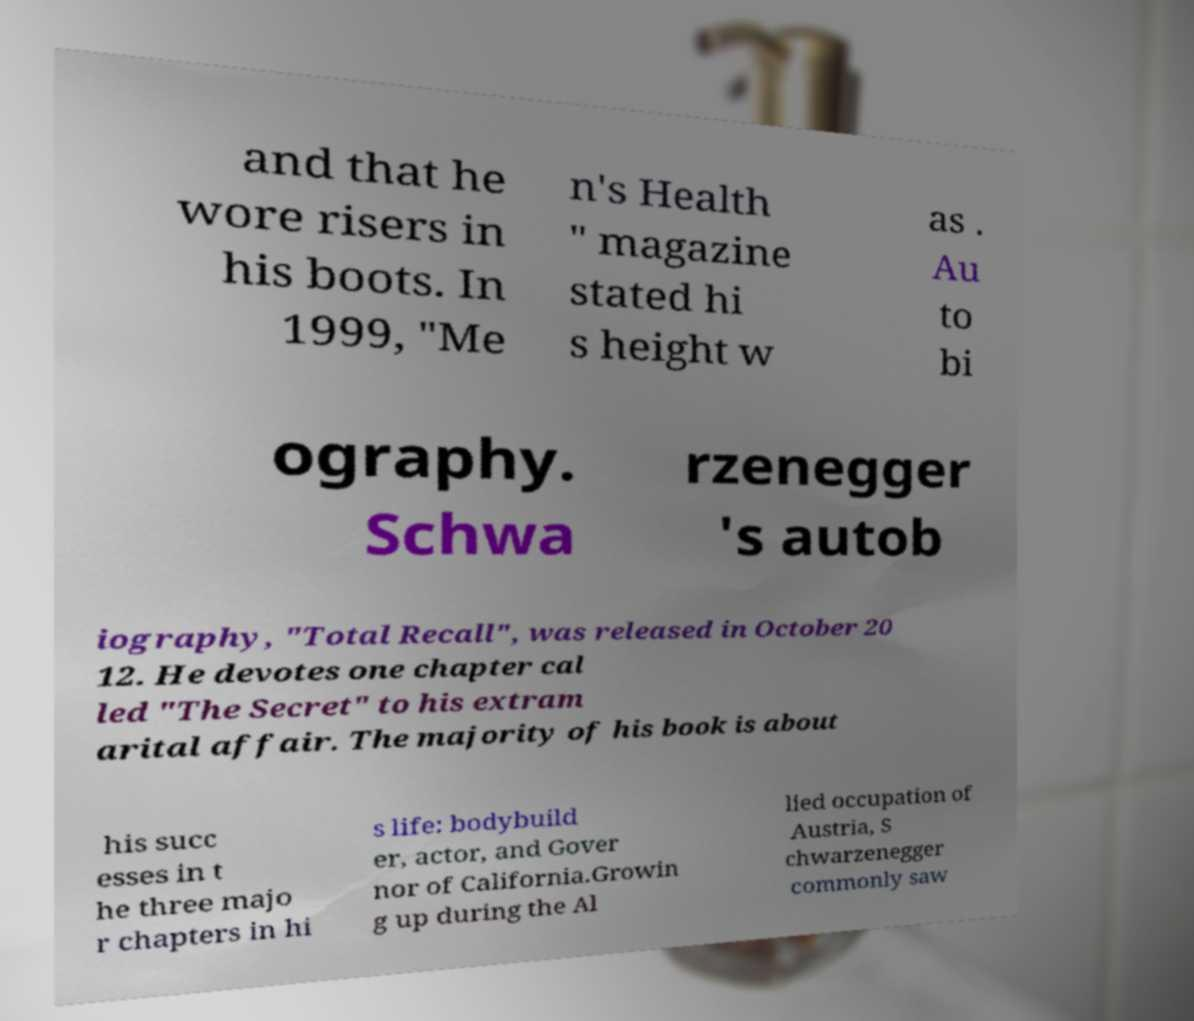There's text embedded in this image that I need extracted. Can you transcribe it verbatim? and that he wore risers in his boots. In 1999, "Me n's Health " magazine stated hi s height w as . Au to bi ography. Schwa rzenegger 's autob iography, "Total Recall", was released in October 20 12. He devotes one chapter cal led "The Secret" to his extram arital affair. The majority of his book is about his succ esses in t he three majo r chapters in hi s life: bodybuild er, actor, and Gover nor of California.Growin g up during the Al lied occupation of Austria, S chwarzenegger commonly saw 